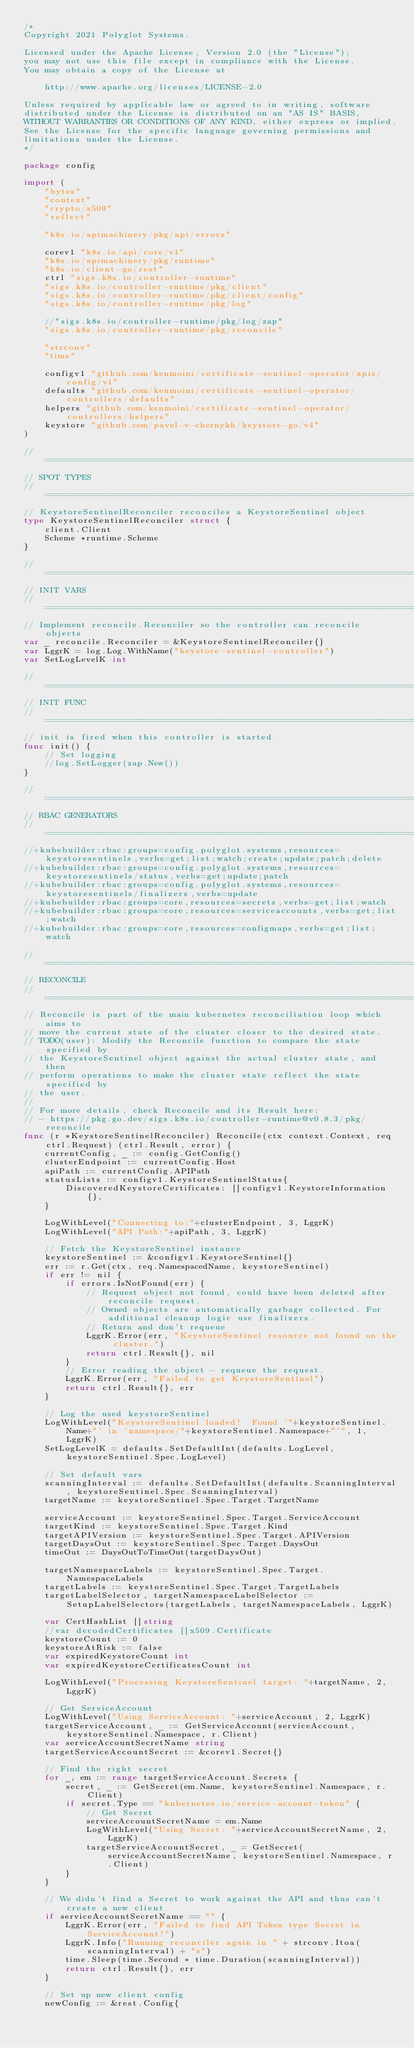Convert code to text. <code><loc_0><loc_0><loc_500><loc_500><_Go_>/*
Copyright 2021 Polyglot Systems.

Licensed under the Apache License, Version 2.0 (the "License");
you may not use this file except in compliance with the License.
You may obtain a copy of the License at

    http://www.apache.org/licenses/LICENSE-2.0

Unless required by applicable law or agreed to in writing, software
distributed under the License is distributed on an "AS IS" BASIS,
WITHOUT WARRANTIES OR CONDITIONS OF ANY KIND, either express or implied.
See the License for the specific language governing permissions and
limitations under the License.
*/

package config

import (
	"bytes"
	"context"
	"crypto/x509"
	"reflect"

	"k8s.io/apimachinery/pkg/api/errors"

	corev1 "k8s.io/api/core/v1"
	"k8s.io/apimachinery/pkg/runtime"
	"k8s.io/client-go/rest"
	ctrl "sigs.k8s.io/controller-runtime"
	"sigs.k8s.io/controller-runtime/pkg/client"
	"sigs.k8s.io/controller-runtime/pkg/client/config"
	"sigs.k8s.io/controller-runtime/pkg/log"

	//"sigs.k8s.io/controller-runtime/pkg/log/zap"
	"sigs.k8s.io/controller-runtime/pkg/reconcile"

	"strconv"
	"time"

	configv1 "github.com/kenmoini/certificate-sentinel-operator/apis/config/v1"
	defaults "github.com/kenmoini/certificate-sentinel-operator/controllers/defaults"
	helpers "github.com/kenmoini/certificate-sentinel-operator/controllers/helpers"
	keystore "github.com/pavel-v-chernykh/keystore-go/v4"
)

//===========================================================================================
// SPOT TYPES
//===========================================================================================
// KeystoreSentinelReconciler reconciles a KeystoreSentinel object
type KeystoreSentinelReconciler struct {
	client.Client
	Scheme *runtime.Scheme
}

//===========================================================================================
// INIT VARS
//===========================================================================================
// Implement reconcile.Reconciler so the controller can reconcile objects
var _ reconcile.Reconciler = &KeystoreSentinelReconciler{}
var LggrK = log.Log.WithName("keystore-sentinel-controller")
var SetLogLevelK int

//===========================================================================================
// INIT FUNC
//===========================================================================================
// init is fired when this controller is started
func init() {
	// Set logging
	//log.SetLogger(zap.New())
}

//===========================================================================================
// RBAC GENERATORS
//===========================================================================================
//+kubebuilder:rbac:groups=config.polyglot.systems,resources=keystoresentinels,verbs=get;list;watch;create;update;patch;delete
//+kubebuilder:rbac:groups=config.polyglot.systems,resources=keystoresentinels/status,verbs=get;update;patch
//+kubebuilder:rbac:groups=config.polyglot.systems,resources=keystoresentinels/finalizers,verbs=update
//+kubebuilder:rbac:groups=core,resources=secrets,verbs=get;list;watch
//+kubebuilder:rbac:groups=core,resources=serviceaccounts,verbs=get;list;watch
//+kubebuilder:rbac:groups=core,resources=configmaps,verbs=get;list;watch

//===========================================================================================
// RECONCILE
//===========================================================================================
// Reconcile is part of the main kubernetes reconciliation loop which aims to
// move the current state of the cluster closer to the desired state.
// TODO(user): Modify the Reconcile function to compare the state specified by
// the KeystoreSentinel object against the actual cluster state, and then
// perform operations to make the cluster state reflect the state specified by
// the user.
//
// For more details, check Reconcile and its Result here:
// - https://pkg.go.dev/sigs.k8s.io/controller-runtime@v0.8.3/pkg/reconcile
func (r *KeystoreSentinelReconciler) Reconcile(ctx context.Context, req ctrl.Request) (ctrl.Result, error) {
	currentConfig, _ := config.GetConfig()
	clusterEndpoint := currentConfig.Host
	apiPath := currentConfig.APIPath
	statusLists := configv1.KeystoreSentinelStatus{
		DiscoveredKeystoreCertificates: []configv1.KeystoreInformation{},
	}

	LogWithLevel("Connecting to:"+clusterEndpoint, 3, LggrK)
	LogWithLevel("API Path:"+apiPath, 3, LggrK)

	// Fetch the KeystoreSentinel instance
	keystoreSentinel := &configv1.KeystoreSentinel{}
	err := r.Get(ctx, req.NamespacedName, keystoreSentinel)
	if err != nil {
		if errors.IsNotFound(err) {
			// Request object not found, could have been deleted after reconcile request.
			// Owned objects are automatically garbage collected. For additional cleanup logic use finalizers.
			// Return and don't requeue
			LggrK.Error(err, "KeystoreSentinel resource not found on the cluster.")
			return ctrl.Result{}, nil
		}
		// Error reading the object - requeue the request.
		LggrK.Error(err, "Failed to get KeystoreSentinel")
		return ctrl.Result{}, err
	}

	// Log the used keystoreSentinel
	LogWithLevel("KeystoreSentinel loaded!  Found '"+keystoreSentinel.Name+"' in 'namespace/"+keystoreSentinel.Namespace+"'", 1, LggrK)
	SetLogLevelK = defaults.SetDefaultInt(defaults.LogLevel, keystoreSentinel.Spec.LogLevel)

	// Set default vars
	scanningInterval := defaults.SetDefaultInt(defaults.ScanningInterval, keystoreSentinel.Spec.ScanningInterval)
	targetName := keystoreSentinel.Spec.Target.TargetName

	serviceAccount := keystoreSentinel.Spec.Target.ServiceAccount
	targetKind := keystoreSentinel.Spec.Target.Kind
	targetAPIVersion := keystoreSentinel.Spec.Target.APIVersion
	targetDaysOut := keystoreSentinel.Spec.Target.DaysOut
	timeOut := DaysOutToTimeOut(targetDaysOut)

	targetNamespaceLabels := keystoreSentinel.Spec.Target.NamespaceLabels
	targetLabels := keystoreSentinel.Spec.Target.TargetLabels
	targetLabelSelector, targetNamespaceLabelSelector := SetupLabelSelectors(targetLabels, targetNamespaceLabels, LggrK)

	var CertHashList []string
	//var decodedCertificates []x509.Certificate
	keystoreCount := 0
	keystoreAtRisk := false
	var expiredKeystoreCount int
	var expiredKeystoreCertificatesCount int

	LogWithLevel("Processing KeystoreSentinel target: "+targetName, 2, LggrK)

	// Get ServiceAccount
	LogWithLevel("Using ServiceAccount: "+serviceAccount, 2, LggrK)
	targetServiceAccount, _ := GetServiceAccount(serviceAccount, keystoreSentinel.Namespace, r.Client)
	var serviceAccountSecretName string
	targetServiceAccountSecret := &corev1.Secret{}

	// Find the right secret
	for _, em := range targetServiceAccount.Secrets {
		secret, _ := GetSecret(em.Name, keystoreSentinel.Namespace, r.Client)
		if secret.Type == "kubernetes.io/service-account-token" {
			// Get Secret
			serviceAccountSecretName = em.Name
			LogWithLevel("Using Secret: "+serviceAccountSecretName, 2, LggrK)
			targetServiceAccountSecret, _ = GetSecret(serviceAccountSecretName, keystoreSentinel.Namespace, r.Client)
		}
	}

	// We didn't find a Secret to work against the API and thus can't create a new client
	if serviceAccountSecretName == "" {
		LggrK.Error(err, "Failed to find API Token type Secret in ServiceAccount!")
		LggrK.Info("Running reconciler again in " + strconv.Itoa(scanningInterval) + "s")
		time.Sleep(time.Second * time.Duration(scanningInterval))
		return ctrl.Result{}, err
	}

	// Set up new client config
	newConfig := &rest.Config{</code> 